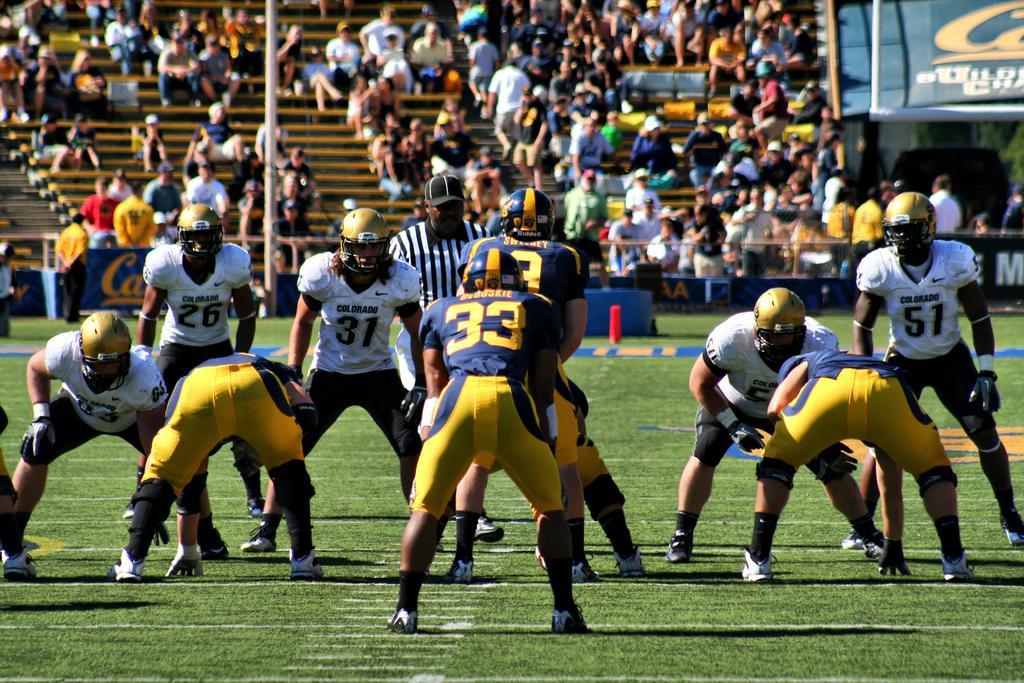Describe this image in one or two sentences. In this image there are people, benches, hoardings, pole and objects. Among them few people are sitting and few people wore helmets. Land is covered with grass.   